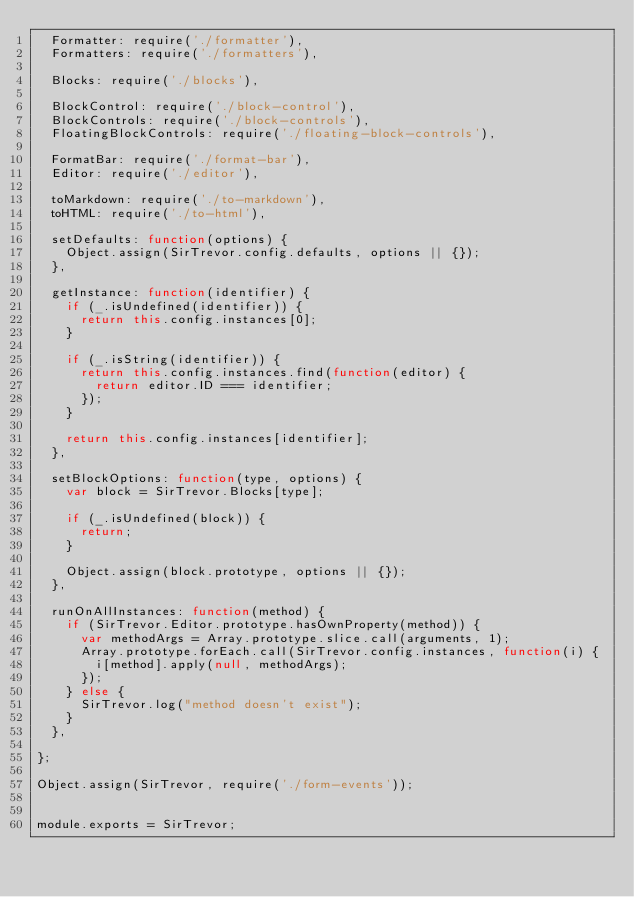<code> <loc_0><loc_0><loc_500><loc_500><_JavaScript_>  Formatter: require('./formatter'),
  Formatters: require('./formatters'),

  Blocks: require('./blocks'),

  BlockControl: require('./block-control'),
  BlockControls: require('./block-controls'),
  FloatingBlockControls: require('./floating-block-controls'),

  FormatBar: require('./format-bar'),
  Editor: require('./editor'),

  toMarkdown: require('./to-markdown'),
  toHTML: require('./to-html'),

  setDefaults: function(options) {
    Object.assign(SirTrevor.config.defaults, options || {});
  },

  getInstance: function(identifier) {
    if (_.isUndefined(identifier)) {
      return this.config.instances[0];
    }

    if (_.isString(identifier)) {
      return this.config.instances.find(function(editor) {
        return editor.ID === identifier;
      });
    }

    return this.config.instances[identifier];
  },

  setBlockOptions: function(type, options) {
    var block = SirTrevor.Blocks[type];

    if (_.isUndefined(block)) {
      return;
    }

    Object.assign(block.prototype, options || {});
  },

  runOnAllInstances: function(method) {
    if (SirTrevor.Editor.prototype.hasOwnProperty(method)) {
      var methodArgs = Array.prototype.slice.call(arguments, 1);
      Array.prototype.forEach.call(SirTrevor.config.instances, function(i) {
        i[method].apply(null, methodArgs);
      });
    } else {
      SirTrevor.log("method doesn't exist");
    }
  },

};

Object.assign(SirTrevor, require('./form-events'));


module.exports = SirTrevor;
</code> 